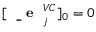Convert formula to latex. <formula><loc_0><loc_0><loc_500><loc_500>[ { e } _ { j } ^ { V C } ] _ { 0 } = 0</formula> 